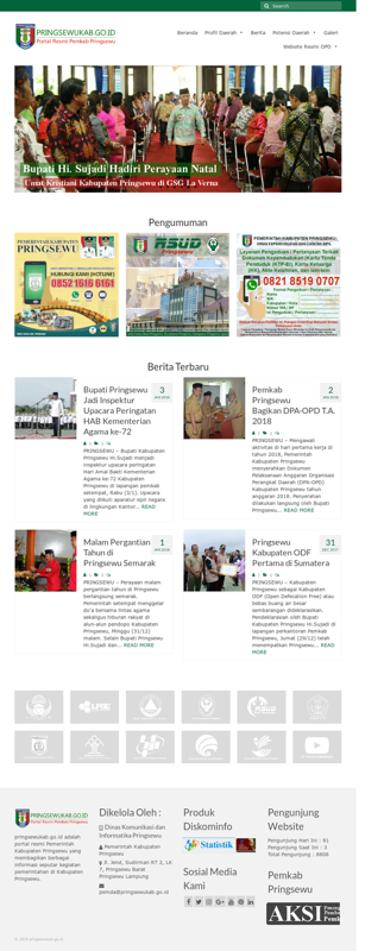Can you tell me what events are currently being promoted on the website? Currently, the website is promoting several events, including a Christmas celebration attended by local government officials and a New Year's Eve prayer meeting, reflecting the cultural and communal activities of the region. 